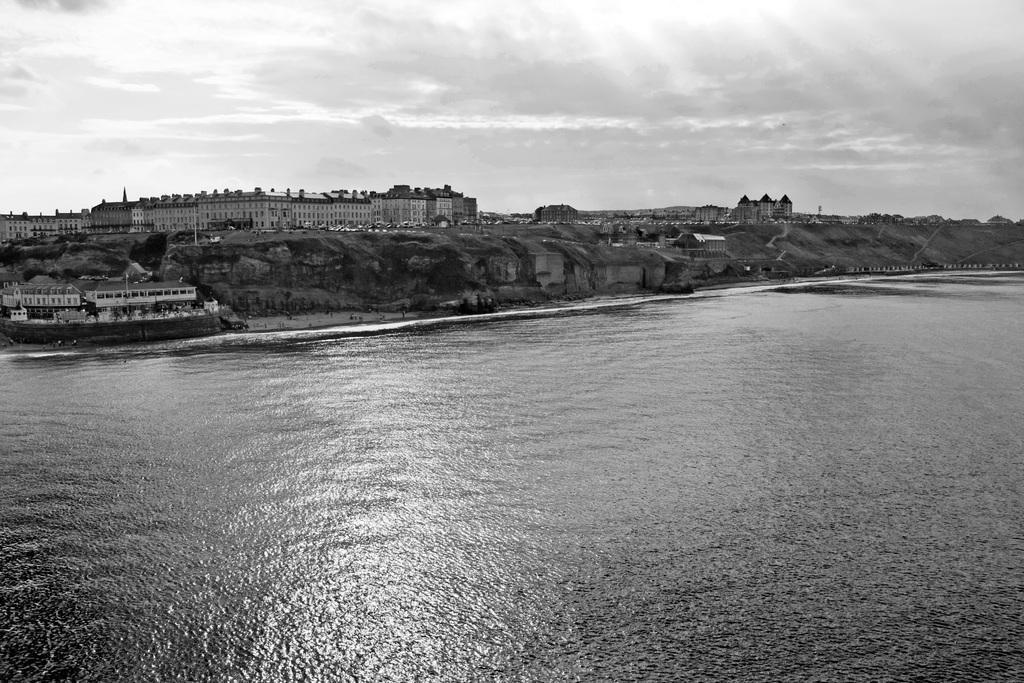Please provide a concise description of this image. In this image we can see there is a river and buildings at the bank of the river. 